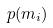<formula> <loc_0><loc_0><loc_500><loc_500>p ( m _ { i } )</formula> 